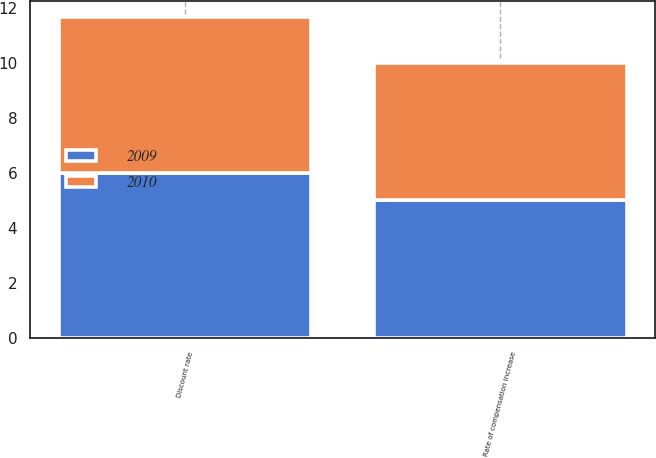Convert chart to OTSL. <chart><loc_0><loc_0><loc_500><loc_500><stacked_bar_chart><ecel><fcel>Discount rate<fcel>Rate of compensation increase<nl><fcel>2010<fcel>5.65<fcel>5<nl><fcel>2009<fcel>6<fcel>5<nl></chart> 